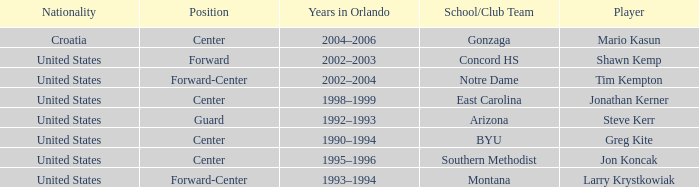What years in Orlando have the United States as the nationality, with concord hs as the school/club team? 2002–2003. 